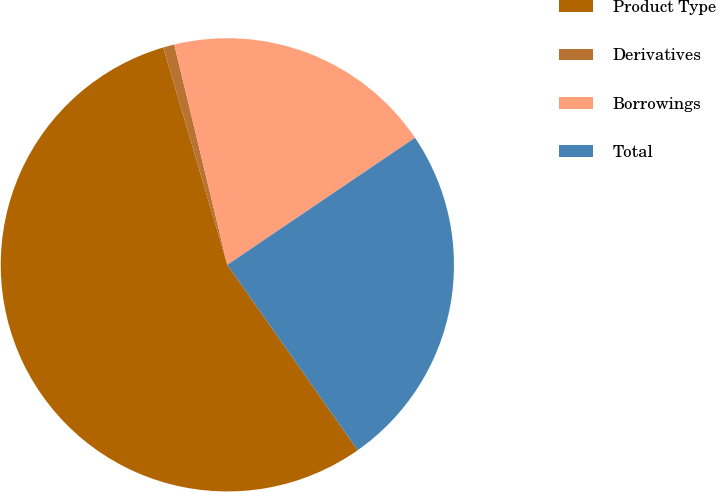Convert chart to OTSL. <chart><loc_0><loc_0><loc_500><loc_500><pie_chart><fcel>Product Type<fcel>Derivatives<fcel>Borrowings<fcel>Total<nl><fcel>55.19%<fcel>0.8%<fcel>19.29%<fcel>24.72%<nl></chart> 